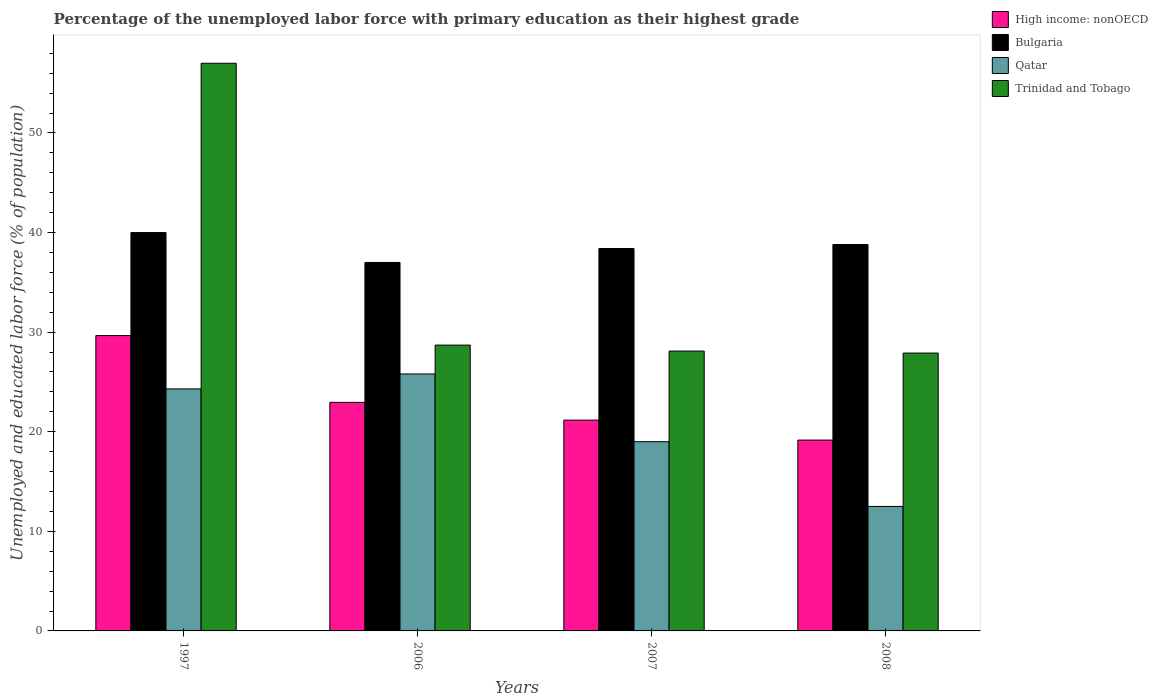How many different coloured bars are there?
Provide a succinct answer. 4. How many groups of bars are there?
Provide a succinct answer. 4. Are the number of bars on each tick of the X-axis equal?
Your answer should be compact. Yes. How many bars are there on the 3rd tick from the right?
Your answer should be compact. 4. What is the percentage of the unemployed labor force with primary education in High income: nonOECD in 2007?
Provide a short and direct response. 21.17. Across all years, what is the maximum percentage of the unemployed labor force with primary education in Qatar?
Provide a short and direct response. 25.8. Across all years, what is the minimum percentage of the unemployed labor force with primary education in Trinidad and Tobago?
Offer a very short reply. 27.9. In which year was the percentage of the unemployed labor force with primary education in Trinidad and Tobago minimum?
Make the answer very short. 2008. What is the total percentage of the unemployed labor force with primary education in High income: nonOECD in the graph?
Ensure brevity in your answer.  92.94. What is the difference between the percentage of the unemployed labor force with primary education in Qatar in 1997 and that in 2007?
Your answer should be compact. 5.3. What is the difference between the percentage of the unemployed labor force with primary education in Trinidad and Tobago in 2007 and the percentage of the unemployed labor force with primary education in High income: nonOECD in 2006?
Provide a short and direct response. 5.15. What is the average percentage of the unemployed labor force with primary education in High income: nonOECD per year?
Your answer should be very brief. 23.23. In the year 2008, what is the difference between the percentage of the unemployed labor force with primary education in Trinidad and Tobago and percentage of the unemployed labor force with primary education in High income: nonOECD?
Ensure brevity in your answer.  8.74. What is the ratio of the percentage of the unemployed labor force with primary education in Qatar in 1997 to that in 2008?
Offer a terse response. 1.94. Is the percentage of the unemployed labor force with primary education in Qatar in 1997 less than that in 2007?
Offer a terse response. No. What is the difference between the highest and the second highest percentage of the unemployed labor force with primary education in High income: nonOECD?
Your response must be concise. 6.71. What is the difference between the highest and the lowest percentage of the unemployed labor force with primary education in High income: nonOECD?
Offer a terse response. 10.49. In how many years, is the percentage of the unemployed labor force with primary education in Bulgaria greater than the average percentage of the unemployed labor force with primary education in Bulgaria taken over all years?
Your answer should be compact. 2. Is the sum of the percentage of the unemployed labor force with primary education in High income: nonOECD in 1997 and 2006 greater than the maximum percentage of the unemployed labor force with primary education in Bulgaria across all years?
Keep it short and to the point. Yes. Is it the case that in every year, the sum of the percentage of the unemployed labor force with primary education in High income: nonOECD and percentage of the unemployed labor force with primary education in Trinidad and Tobago is greater than the sum of percentage of the unemployed labor force with primary education in Bulgaria and percentage of the unemployed labor force with primary education in Qatar?
Keep it short and to the point. Yes. What does the 4th bar from the left in 2008 represents?
Offer a terse response. Trinidad and Tobago. What does the 1st bar from the right in 2007 represents?
Your answer should be very brief. Trinidad and Tobago. Is it the case that in every year, the sum of the percentage of the unemployed labor force with primary education in High income: nonOECD and percentage of the unemployed labor force with primary education in Bulgaria is greater than the percentage of the unemployed labor force with primary education in Qatar?
Make the answer very short. Yes. How many bars are there?
Provide a succinct answer. 16. Are all the bars in the graph horizontal?
Offer a terse response. No. What is the difference between two consecutive major ticks on the Y-axis?
Offer a very short reply. 10. Where does the legend appear in the graph?
Offer a terse response. Top right. How many legend labels are there?
Ensure brevity in your answer.  4. How are the legend labels stacked?
Your response must be concise. Vertical. What is the title of the graph?
Ensure brevity in your answer.  Percentage of the unemployed labor force with primary education as their highest grade. Does "Lebanon" appear as one of the legend labels in the graph?
Offer a terse response. No. What is the label or title of the X-axis?
Offer a terse response. Years. What is the label or title of the Y-axis?
Provide a succinct answer. Unemployed and educated labor force (% of population). What is the Unemployed and educated labor force (% of population) in High income: nonOECD in 1997?
Your answer should be very brief. 29.66. What is the Unemployed and educated labor force (% of population) in Qatar in 1997?
Make the answer very short. 24.3. What is the Unemployed and educated labor force (% of population) in High income: nonOECD in 2006?
Provide a short and direct response. 22.95. What is the Unemployed and educated labor force (% of population) of Qatar in 2006?
Make the answer very short. 25.8. What is the Unemployed and educated labor force (% of population) in Trinidad and Tobago in 2006?
Make the answer very short. 28.7. What is the Unemployed and educated labor force (% of population) of High income: nonOECD in 2007?
Your response must be concise. 21.17. What is the Unemployed and educated labor force (% of population) of Bulgaria in 2007?
Keep it short and to the point. 38.4. What is the Unemployed and educated labor force (% of population) in Trinidad and Tobago in 2007?
Offer a very short reply. 28.1. What is the Unemployed and educated labor force (% of population) of High income: nonOECD in 2008?
Your answer should be very brief. 19.16. What is the Unemployed and educated labor force (% of population) of Bulgaria in 2008?
Provide a short and direct response. 38.8. What is the Unemployed and educated labor force (% of population) of Trinidad and Tobago in 2008?
Keep it short and to the point. 27.9. Across all years, what is the maximum Unemployed and educated labor force (% of population) of High income: nonOECD?
Your answer should be compact. 29.66. Across all years, what is the maximum Unemployed and educated labor force (% of population) of Bulgaria?
Offer a terse response. 40. Across all years, what is the maximum Unemployed and educated labor force (% of population) in Qatar?
Give a very brief answer. 25.8. Across all years, what is the minimum Unemployed and educated labor force (% of population) in High income: nonOECD?
Ensure brevity in your answer.  19.16. Across all years, what is the minimum Unemployed and educated labor force (% of population) in Qatar?
Your answer should be very brief. 12.5. Across all years, what is the minimum Unemployed and educated labor force (% of population) in Trinidad and Tobago?
Ensure brevity in your answer.  27.9. What is the total Unemployed and educated labor force (% of population) in High income: nonOECD in the graph?
Give a very brief answer. 92.94. What is the total Unemployed and educated labor force (% of population) in Bulgaria in the graph?
Your response must be concise. 154.2. What is the total Unemployed and educated labor force (% of population) of Qatar in the graph?
Make the answer very short. 81.6. What is the total Unemployed and educated labor force (% of population) of Trinidad and Tobago in the graph?
Your answer should be very brief. 141.7. What is the difference between the Unemployed and educated labor force (% of population) of High income: nonOECD in 1997 and that in 2006?
Provide a short and direct response. 6.71. What is the difference between the Unemployed and educated labor force (% of population) in Trinidad and Tobago in 1997 and that in 2006?
Offer a very short reply. 28.3. What is the difference between the Unemployed and educated labor force (% of population) in High income: nonOECD in 1997 and that in 2007?
Your answer should be compact. 8.49. What is the difference between the Unemployed and educated labor force (% of population) of Trinidad and Tobago in 1997 and that in 2007?
Offer a very short reply. 28.9. What is the difference between the Unemployed and educated labor force (% of population) of High income: nonOECD in 1997 and that in 2008?
Ensure brevity in your answer.  10.49. What is the difference between the Unemployed and educated labor force (% of population) of Trinidad and Tobago in 1997 and that in 2008?
Your answer should be very brief. 29.1. What is the difference between the Unemployed and educated labor force (% of population) of High income: nonOECD in 2006 and that in 2007?
Ensure brevity in your answer.  1.78. What is the difference between the Unemployed and educated labor force (% of population) of High income: nonOECD in 2006 and that in 2008?
Provide a short and direct response. 3.79. What is the difference between the Unemployed and educated labor force (% of population) in Qatar in 2006 and that in 2008?
Ensure brevity in your answer.  13.3. What is the difference between the Unemployed and educated labor force (% of population) in Trinidad and Tobago in 2006 and that in 2008?
Make the answer very short. 0.8. What is the difference between the Unemployed and educated labor force (% of population) in High income: nonOECD in 2007 and that in 2008?
Provide a succinct answer. 2.01. What is the difference between the Unemployed and educated labor force (% of population) in Qatar in 2007 and that in 2008?
Your answer should be compact. 6.5. What is the difference between the Unemployed and educated labor force (% of population) in High income: nonOECD in 1997 and the Unemployed and educated labor force (% of population) in Bulgaria in 2006?
Offer a very short reply. -7.34. What is the difference between the Unemployed and educated labor force (% of population) in High income: nonOECD in 1997 and the Unemployed and educated labor force (% of population) in Qatar in 2006?
Provide a short and direct response. 3.86. What is the difference between the Unemployed and educated labor force (% of population) in High income: nonOECD in 1997 and the Unemployed and educated labor force (% of population) in Trinidad and Tobago in 2006?
Make the answer very short. 0.96. What is the difference between the Unemployed and educated labor force (% of population) of Bulgaria in 1997 and the Unemployed and educated labor force (% of population) of Qatar in 2006?
Your response must be concise. 14.2. What is the difference between the Unemployed and educated labor force (% of population) in Bulgaria in 1997 and the Unemployed and educated labor force (% of population) in Trinidad and Tobago in 2006?
Give a very brief answer. 11.3. What is the difference between the Unemployed and educated labor force (% of population) of High income: nonOECD in 1997 and the Unemployed and educated labor force (% of population) of Bulgaria in 2007?
Offer a very short reply. -8.74. What is the difference between the Unemployed and educated labor force (% of population) of High income: nonOECD in 1997 and the Unemployed and educated labor force (% of population) of Qatar in 2007?
Ensure brevity in your answer.  10.66. What is the difference between the Unemployed and educated labor force (% of population) of High income: nonOECD in 1997 and the Unemployed and educated labor force (% of population) of Trinidad and Tobago in 2007?
Offer a terse response. 1.56. What is the difference between the Unemployed and educated labor force (% of population) in Bulgaria in 1997 and the Unemployed and educated labor force (% of population) in Trinidad and Tobago in 2007?
Offer a very short reply. 11.9. What is the difference between the Unemployed and educated labor force (% of population) in High income: nonOECD in 1997 and the Unemployed and educated labor force (% of population) in Bulgaria in 2008?
Provide a short and direct response. -9.14. What is the difference between the Unemployed and educated labor force (% of population) in High income: nonOECD in 1997 and the Unemployed and educated labor force (% of population) in Qatar in 2008?
Your answer should be very brief. 17.16. What is the difference between the Unemployed and educated labor force (% of population) in High income: nonOECD in 1997 and the Unemployed and educated labor force (% of population) in Trinidad and Tobago in 2008?
Make the answer very short. 1.76. What is the difference between the Unemployed and educated labor force (% of population) of Bulgaria in 1997 and the Unemployed and educated labor force (% of population) of Qatar in 2008?
Give a very brief answer. 27.5. What is the difference between the Unemployed and educated labor force (% of population) in Qatar in 1997 and the Unemployed and educated labor force (% of population) in Trinidad and Tobago in 2008?
Your answer should be compact. -3.6. What is the difference between the Unemployed and educated labor force (% of population) of High income: nonOECD in 2006 and the Unemployed and educated labor force (% of population) of Bulgaria in 2007?
Ensure brevity in your answer.  -15.45. What is the difference between the Unemployed and educated labor force (% of population) of High income: nonOECD in 2006 and the Unemployed and educated labor force (% of population) of Qatar in 2007?
Your answer should be very brief. 3.95. What is the difference between the Unemployed and educated labor force (% of population) of High income: nonOECD in 2006 and the Unemployed and educated labor force (% of population) of Trinidad and Tobago in 2007?
Provide a short and direct response. -5.15. What is the difference between the Unemployed and educated labor force (% of population) in Bulgaria in 2006 and the Unemployed and educated labor force (% of population) in Qatar in 2007?
Provide a succinct answer. 18. What is the difference between the Unemployed and educated labor force (% of population) in Bulgaria in 2006 and the Unemployed and educated labor force (% of population) in Trinidad and Tobago in 2007?
Your response must be concise. 8.9. What is the difference between the Unemployed and educated labor force (% of population) in High income: nonOECD in 2006 and the Unemployed and educated labor force (% of population) in Bulgaria in 2008?
Ensure brevity in your answer.  -15.85. What is the difference between the Unemployed and educated labor force (% of population) in High income: nonOECD in 2006 and the Unemployed and educated labor force (% of population) in Qatar in 2008?
Give a very brief answer. 10.45. What is the difference between the Unemployed and educated labor force (% of population) in High income: nonOECD in 2006 and the Unemployed and educated labor force (% of population) in Trinidad and Tobago in 2008?
Provide a short and direct response. -4.95. What is the difference between the Unemployed and educated labor force (% of population) in Bulgaria in 2006 and the Unemployed and educated labor force (% of population) in Trinidad and Tobago in 2008?
Make the answer very short. 9.1. What is the difference between the Unemployed and educated labor force (% of population) in Qatar in 2006 and the Unemployed and educated labor force (% of population) in Trinidad and Tobago in 2008?
Offer a terse response. -2.1. What is the difference between the Unemployed and educated labor force (% of population) of High income: nonOECD in 2007 and the Unemployed and educated labor force (% of population) of Bulgaria in 2008?
Your response must be concise. -17.63. What is the difference between the Unemployed and educated labor force (% of population) in High income: nonOECD in 2007 and the Unemployed and educated labor force (% of population) in Qatar in 2008?
Your answer should be very brief. 8.67. What is the difference between the Unemployed and educated labor force (% of population) in High income: nonOECD in 2007 and the Unemployed and educated labor force (% of population) in Trinidad and Tobago in 2008?
Offer a terse response. -6.73. What is the difference between the Unemployed and educated labor force (% of population) in Bulgaria in 2007 and the Unemployed and educated labor force (% of population) in Qatar in 2008?
Provide a short and direct response. 25.9. What is the average Unemployed and educated labor force (% of population) of High income: nonOECD per year?
Keep it short and to the point. 23.23. What is the average Unemployed and educated labor force (% of population) of Bulgaria per year?
Offer a very short reply. 38.55. What is the average Unemployed and educated labor force (% of population) in Qatar per year?
Keep it short and to the point. 20.4. What is the average Unemployed and educated labor force (% of population) in Trinidad and Tobago per year?
Provide a succinct answer. 35.42. In the year 1997, what is the difference between the Unemployed and educated labor force (% of population) in High income: nonOECD and Unemployed and educated labor force (% of population) in Bulgaria?
Provide a succinct answer. -10.34. In the year 1997, what is the difference between the Unemployed and educated labor force (% of population) of High income: nonOECD and Unemployed and educated labor force (% of population) of Qatar?
Provide a succinct answer. 5.36. In the year 1997, what is the difference between the Unemployed and educated labor force (% of population) in High income: nonOECD and Unemployed and educated labor force (% of population) in Trinidad and Tobago?
Give a very brief answer. -27.34. In the year 1997, what is the difference between the Unemployed and educated labor force (% of population) in Qatar and Unemployed and educated labor force (% of population) in Trinidad and Tobago?
Provide a short and direct response. -32.7. In the year 2006, what is the difference between the Unemployed and educated labor force (% of population) of High income: nonOECD and Unemployed and educated labor force (% of population) of Bulgaria?
Your answer should be very brief. -14.05. In the year 2006, what is the difference between the Unemployed and educated labor force (% of population) of High income: nonOECD and Unemployed and educated labor force (% of population) of Qatar?
Your response must be concise. -2.85. In the year 2006, what is the difference between the Unemployed and educated labor force (% of population) of High income: nonOECD and Unemployed and educated labor force (% of population) of Trinidad and Tobago?
Make the answer very short. -5.75. In the year 2006, what is the difference between the Unemployed and educated labor force (% of population) in Bulgaria and Unemployed and educated labor force (% of population) in Qatar?
Your answer should be compact. 11.2. In the year 2006, what is the difference between the Unemployed and educated labor force (% of population) in Qatar and Unemployed and educated labor force (% of population) in Trinidad and Tobago?
Your answer should be compact. -2.9. In the year 2007, what is the difference between the Unemployed and educated labor force (% of population) of High income: nonOECD and Unemployed and educated labor force (% of population) of Bulgaria?
Give a very brief answer. -17.23. In the year 2007, what is the difference between the Unemployed and educated labor force (% of population) in High income: nonOECD and Unemployed and educated labor force (% of population) in Qatar?
Keep it short and to the point. 2.17. In the year 2007, what is the difference between the Unemployed and educated labor force (% of population) in High income: nonOECD and Unemployed and educated labor force (% of population) in Trinidad and Tobago?
Your response must be concise. -6.93. In the year 2007, what is the difference between the Unemployed and educated labor force (% of population) of Qatar and Unemployed and educated labor force (% of population) of Trinidad and Tobago?
Keep it short and to the point. -9.1. In the year 2008, what is the difference between the Unemployed and educated labor force (% of population) of High income: nonOECD and Unemployed and educated labor force (% of population) of Bulgaria?
Offer a terse response. -19.64. In the year 2008, what is the difference between the Unemployed and educated labor force (% of population) of High income: nonOECD and Unemployed and educated labor force (% of population) of Qatar?
Offer a very short reply. 6.66. In the year 2008, what is the difference between the Unemployed and educated labor force (% of population) in High income: nonOECD and Unemployed and educated labor force (% of population) in Trinidad and Tobago?
Make the answer very short. -8.74. In the year 2008, what is the difference between the Unemployed and educated labor force (% of population) in Bulgaria and Unemployed and educated labor force (% of population) in Qatar?
Your response must be concise. 26.3. In the year 2008, what is the difference between the Unemployed and educated labor force (% of population) of Qatar and Unemployed and educated labor force (% of population) of Trinidad and Tobago?
Your answer should be compact. -15.4. What is the ratio of the Unemployed and educated labor force (% of population) in High income: nonOECD in 1997 to that in 2006?
Your answer should be very brief. 1.29. What is the ratio of the Unemployed and educated labor force (% of population) in Bulgaria in 1997 to that in 2006?
Your response must be concise. 1.08. What is the ratio of the Unemployed and educated labor force (% of population) of Qatar in 1997 to that in 2006?
Provide a succinct answer. 0.94. What is the ratio of the Unemployed and educated labor force (% of population) of Trinidad and Tobago in 1997 to that in 2006?
Offer a terse response. 1.99. What is the ratio of the Unemployed and educated labor force (% of population) of High income: nonOECD in 1997 to that in 2007?
Your response must be concise. 1.4. What is the ratio of the Unemployed and educated labor force (% of population) of Bulgaria in 1997 to that in 2007?
Offer a very short reply. 1.04. What is the ratio of the Unemployed and educated labor force (% of population) of Qatar in 1997 to that in 2007?
Your response must be concise. 1.28. What is the ratio of the Unemployed and educated labor force (% of population) of Trinidad and Tobago in 1997 to that in 2007?
Your answer should be very brief. 2.03. What is the ratio of the Unemployed and educated labor force (% of population) in High income: nonOECD in 1997 to that in 2008?
Provide a succinct answer. 1.55. What is the ratio of the Unemployed and educated labor force (% of population) of Bulgaria in 1997 to that in 2008?
Provide a short and direct response. 1.03. What is the ratio of the Unemployed and educated labor force (% of population) of Qatar in 1997 to that in 2008?
Give a very brief answer. 1.94. What is the ratio of the Unemployed and educated labor force (% of population) of Trinidad and Tobago in 1997 to that in 2008?
Provide a succinct answer. 2.04. What is the ratio of the Unemployed and educated labor force (% of population) of High income: nonOECD in 2006 to that in 2007?
Make the answer very short. 1.08. What is the ratio of the Unemployed and educated labor force (% of population) of Bulgaria in 2006 to that in 2007?
Offer a very short reply. 0.96. What is the ratio of the Unemployed and educated labor force (% of population) of Qatar in 2006 to that in 2007?
Provide a short and direct response. 1.36. What is the ratio of the Unemployed and educated labor force (% of population) in Trinidad and Tobago in 2006 to that in 2007?
Your answer should be compact. 1.02. What is the ratio of the Unemployed and educated labor force (% of population) of High income: nonOECD in 2006 to that in 2008?
Your answer should be compact. 1.2. What is the ratio of the Unemployed and educated labor force (% of population) of Bulgaria in 2006 to that in 2008?
Your answer should be very brief. 0.95. What is the ratio of the Unemployed and educated labor force (% of population) in Qatar in 2006 to that in 2008?
Make the answer very short. 2.06. What is the ratio of the Unemployed and educated labor force (% of population) in Trinidad and Tobago in 2006 to that in 2008?
Keep it short and to the point. 1.03. What is the ratio of the Unemployed and educated labor force (% of population) in High income: nonOECD in 2007 to that in 2008?
Provide a short and direct response. 1.1. What is the ratio of the Unemployed and educated labor force (% of population) of Bulgaria in 2007 to that in 2008?
Make the answer very short. 0.99. What is the ratio of the Unemployed and educated labor force (% of population) of Qatar in 2007 to that in 2008?
Ensure brevity in your answer.  1.52. What is the difference between the highest and the second highest Unemployed and educated labor force (% of population) of High income: nonOECD?
Your answer should be compact. 6.71. What is the difference between the highest and the second highest Unemployed and educated labor force (% of population) in Bulgaria?
Your answer should be compact. 1.2. What is the difference between the highest and the second highest Unemployed and educated labor force (% of population) in Trinidad and Tobago?
Your answer should be compact. 28.3. What is the difference between the highest and the lowest Unemployed and educated labor force (% of population) in High income: nonOECD?
Your answer should be compact. 10.49. What is the difference between the highest and the lowest Unemployed and educated labor force (% of population) in Bulgaria?
Your response must be concise. 3. What is the difference between the highest and the lowest Unemployed and educated labor force (% of population) in Trinidad and Tobago?
Your answer should be compact. 29.1. 